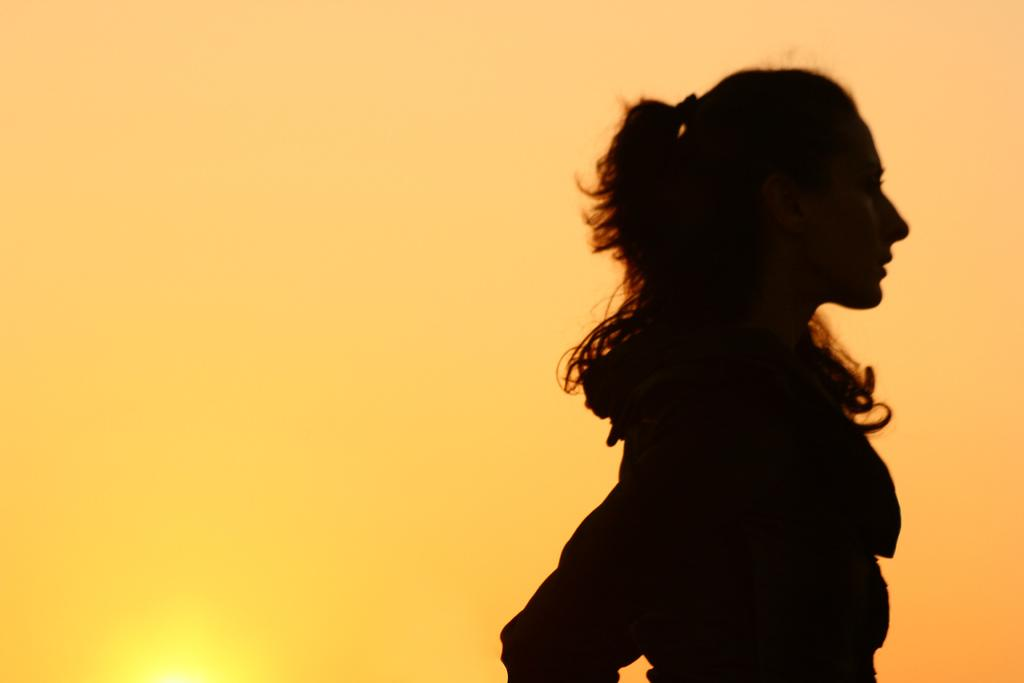Who is the main subject in the image? There is a woman in the image. What is the woman doing in the image? The woman is standing. What can be seen in the background of the image? The sky is visible in the background of the image. How many snails can be seen crawling on the woman's shoulder in the image? There are no snails visible in the image. Is the woman in the image a lawyer? There is no information about the woman's profession in the image, so we cannot determine if she is a lawyer. 